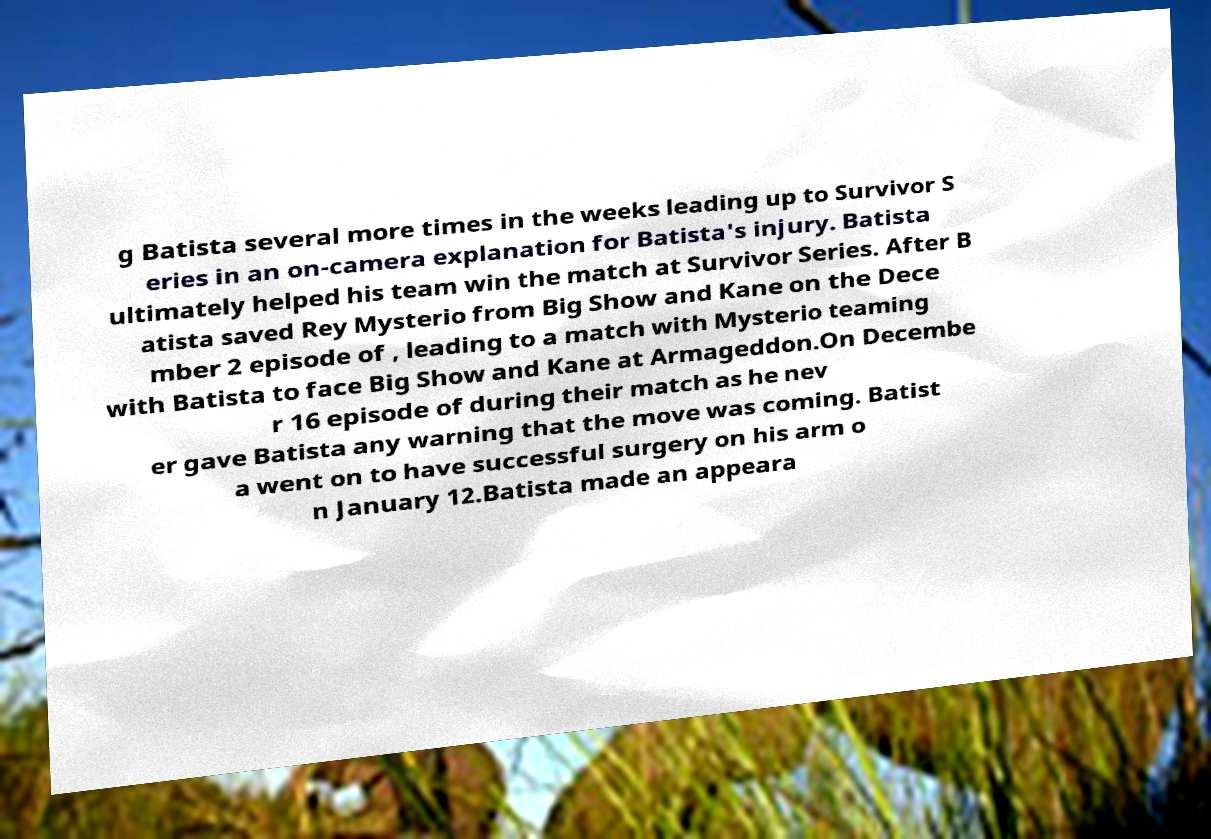For documentation purposes, I need the text within this image transcribed. Could you provide that? g Batista several more times in the weeks leading up to Survivor S eries in an on-camera explanation for Batista's injury. Batista ultimately helped his team win the match at Survivor Series. After B atista saved Rey Mysterio from Big Show and Kane on the Dece mber 2 episode of , leading to a match with Mysterio teaming with Batista to face Big Show and Kane at Armageddon.On Decembe r 16 episode of during their match as he nev er gave Batista any warning that the move was coming. Batist a went on to have successful surgery on his arm o n January 12.Batista made an appeara 